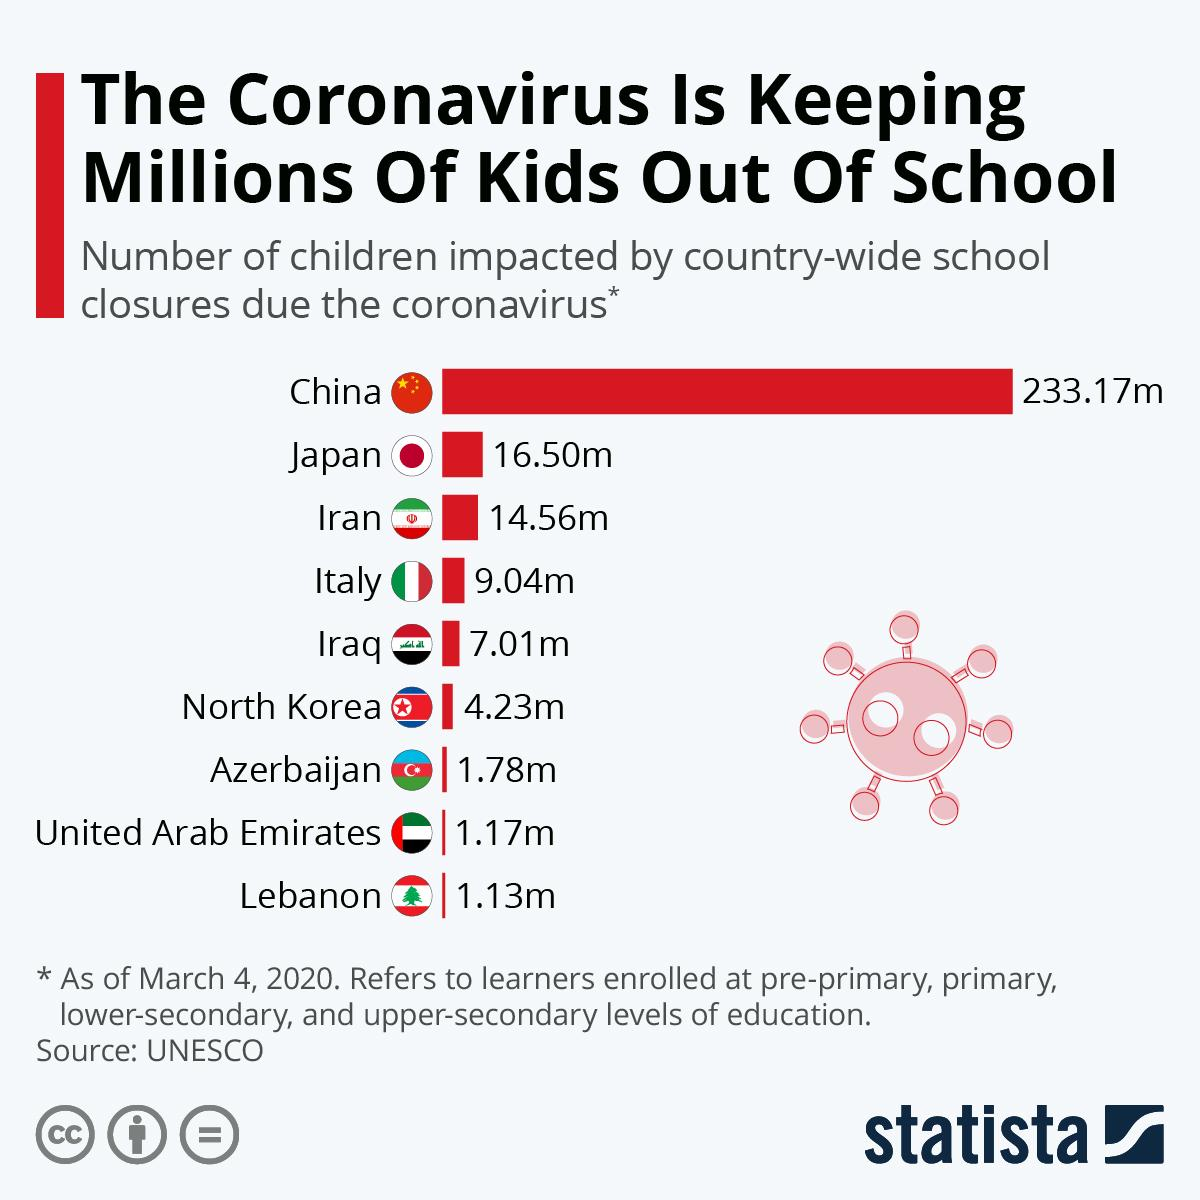Specify some key components in this picture. Azerbaijan, the United Arab Emirates, and Lebanon have fewer than 2 million children affected by the COVID-19 pandemic. Nine countries are included in the survey. The children of China have been the most significantly impacted by school closures due to the COVID-19 pandemic. 